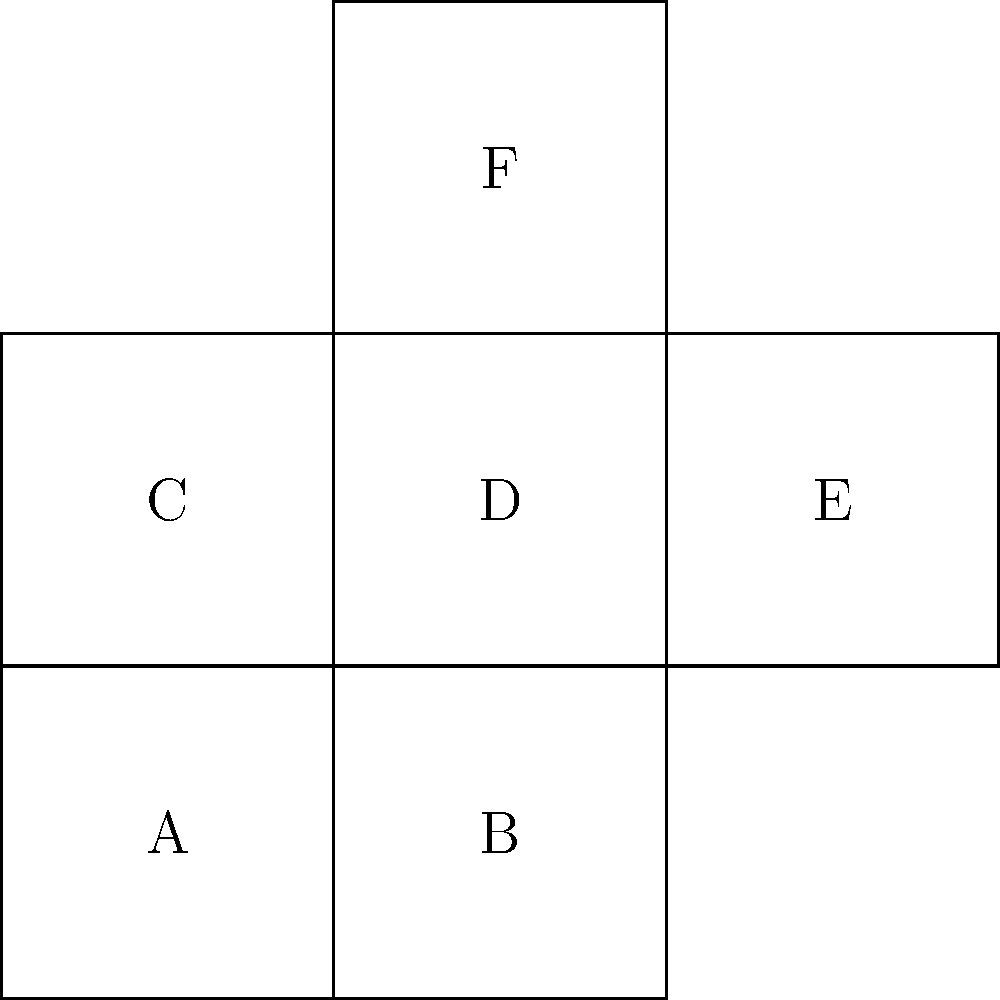As a web developer familiar with spatial concepts in user interface design, analyze the given 2D net diagram. Which 3D shape would this net form when folded along the edges? Additionally, identify which face would be opposite to face 'A' in the resulting 3D shape. To solve this problem, let's follow these steps:

1. Analyze the net diagram:
   - The net consists of 6 square faces connected in a cross-like pattern.
   - Each face is labeled with a letter from A to F.

2. Identify the 3D shape:
   - A net with 6 square faces that can be folded to form a closed shape is characteristic of a cube.
   - The cross-like pattern is a common net representation for a cube.

3. Determine the opposite face to 'A':
   - In a cube, opposite faces are those that cannot share an edge.
   - Looking at the net, we can see that face 'A' shares edges with faces B, C, and D.
   - Face 'E' is connected to 'B' and 'D', but not directly to 'A'.
   - Face 'F' is only connected to 'D'.
   - Therefore, when folded, face 'F' will be opposite to face 'A'.

4. Visualization:
   - Imagine folding the net:
     * 'B' and 'D' fold up to form the sides adjacent to 'A'.
     * 'C' folds to form the top.
     * 'E' folds to form the back.
     * 'F' folds over to form the bottom, opposite to 'A'.

This spatial reasoning is similar to considering the layout of elements in a 3D web design or visualizing the structure of a complex database schema in MySQL.
Answer: Cube; Face F 